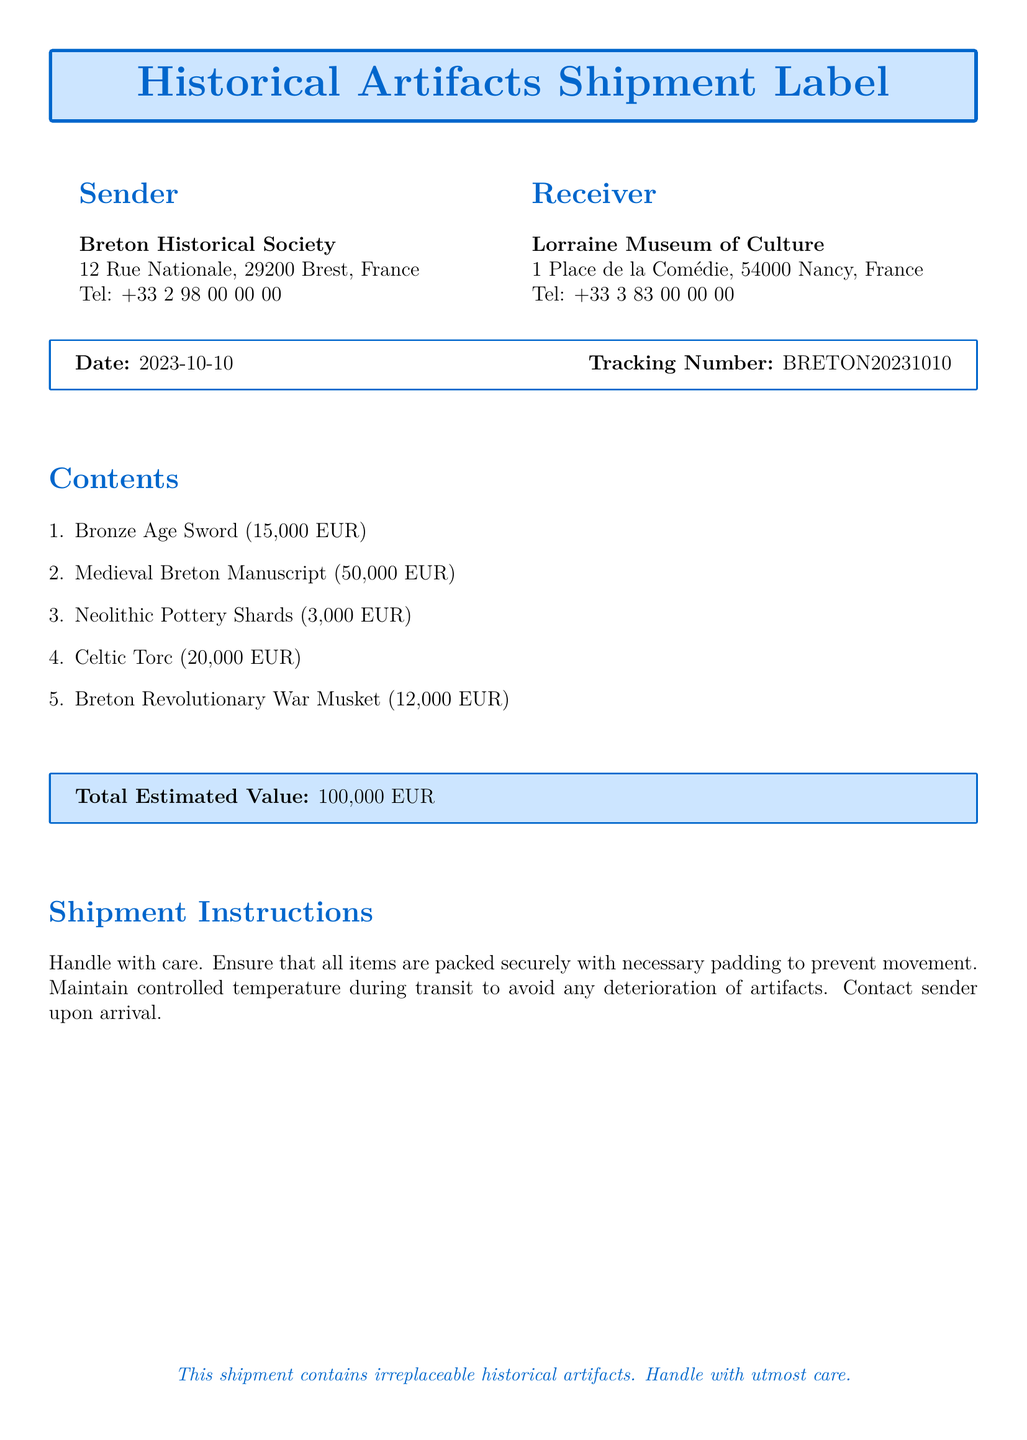What is the sender's name? The sender is identified as the Breton Historical Society at the top of the document.
Answer: Breton Historical Society What is the date of the shipment? The date can be found in the shipment details section of the document.
Answer: 2023-10-10 What is the total estimated value of the shipment? The total value is summarized in a box towards the end of the document.
Answer: 100,000 EUR What item has the highest value? The values of the items are listed, and the Medieval Breton Manuscript has the highest value among them.
Answer: Medieval Breton Manuscript How many items are listed in the shipment? The number of items is indicated by the count in the contents section of the document.
Answer: 5 What are the receiver's contact details? The receiver's contact information is provided in the receiver section of the document.
Answer: +33 3 83 00 00 00 What precautions are instructed for the shipment? The shipment instructions outline the care that should be taken during transit.
Answer: Handle with care What is the value of the Bronze Age Sword? The value is specifically stated in the contents section next to the item.
Answer: 15,000 EUR 